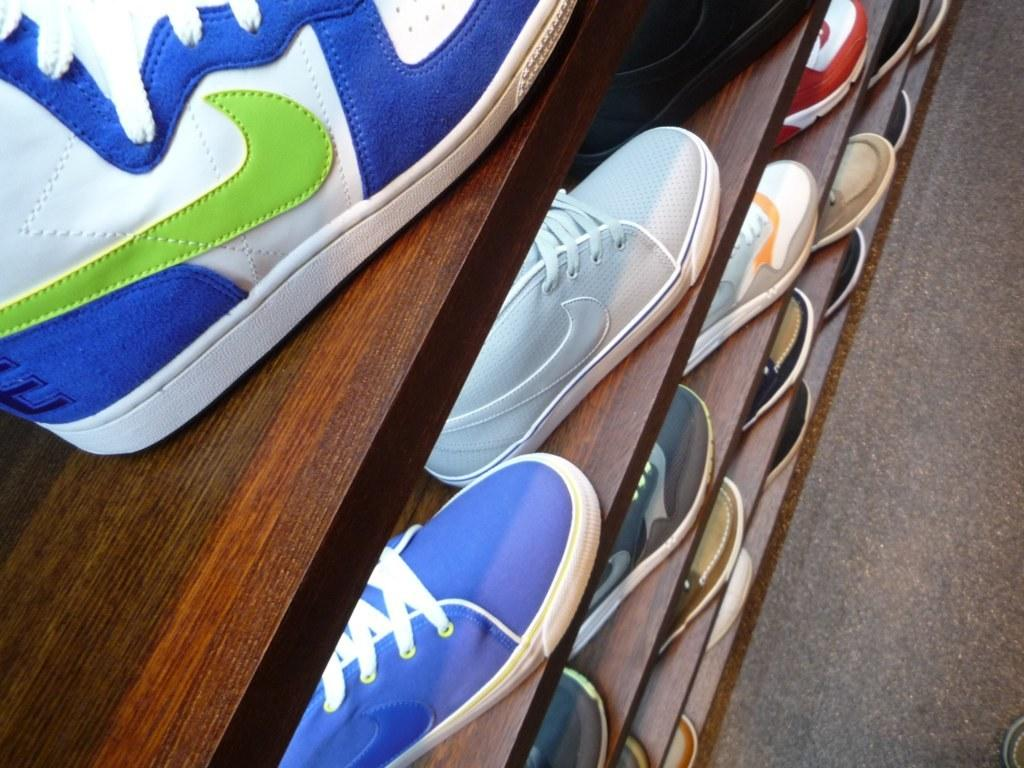What type of items can be seen on the racks in the image? There are shoes on the racks in the image. Can you describe the object on the floor in the right bottom corner of the image? Unfortunately, the facts provided do not give any information about the object on the floor in the right bottom corner of the image. What type of bird can be seen flying over the waves in the image? There is no bird or waves present in the image; it only shows shoes on racks and an object on the floor in the right bottom corner. 